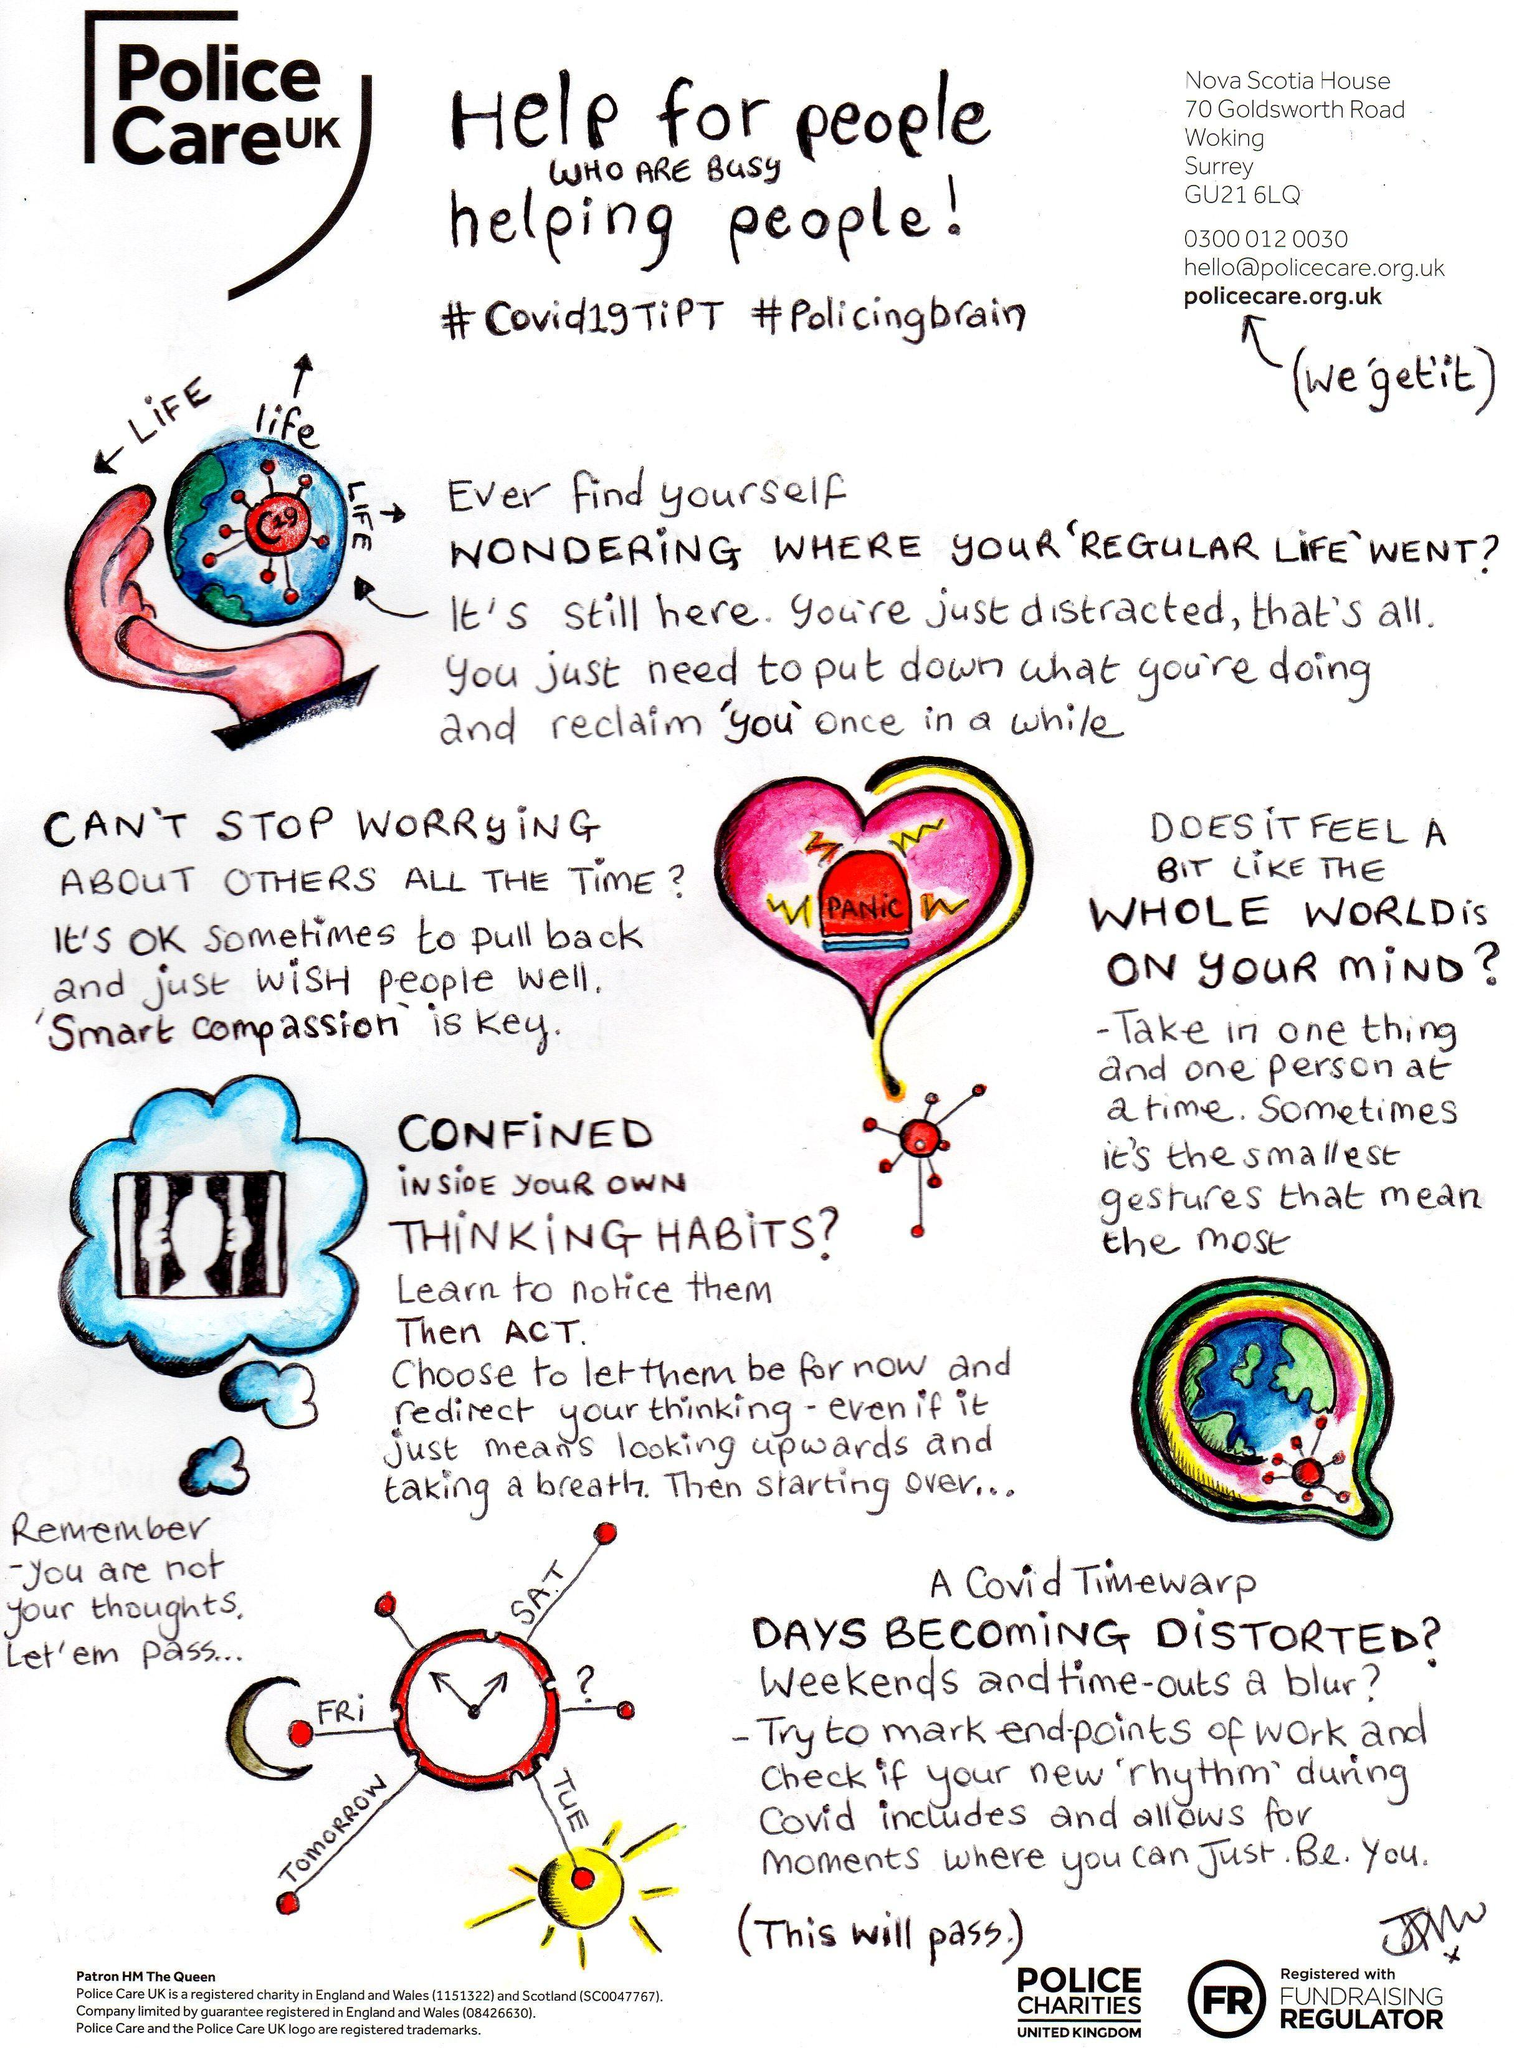What is written within the siren in image of of the heart?
Answer the question with a short phrase. Panic What gets blurred out in a covid timewarp? Weekends and time-outs Who are the people busy helping other people? Police What is the key to stop worrying about other people all the time? Smart compassion What should you do after you learn to notice your 'thinking habits'? Act What are the two hashtags used for Police care UK? #Covid19TiPT, #policingbrain 